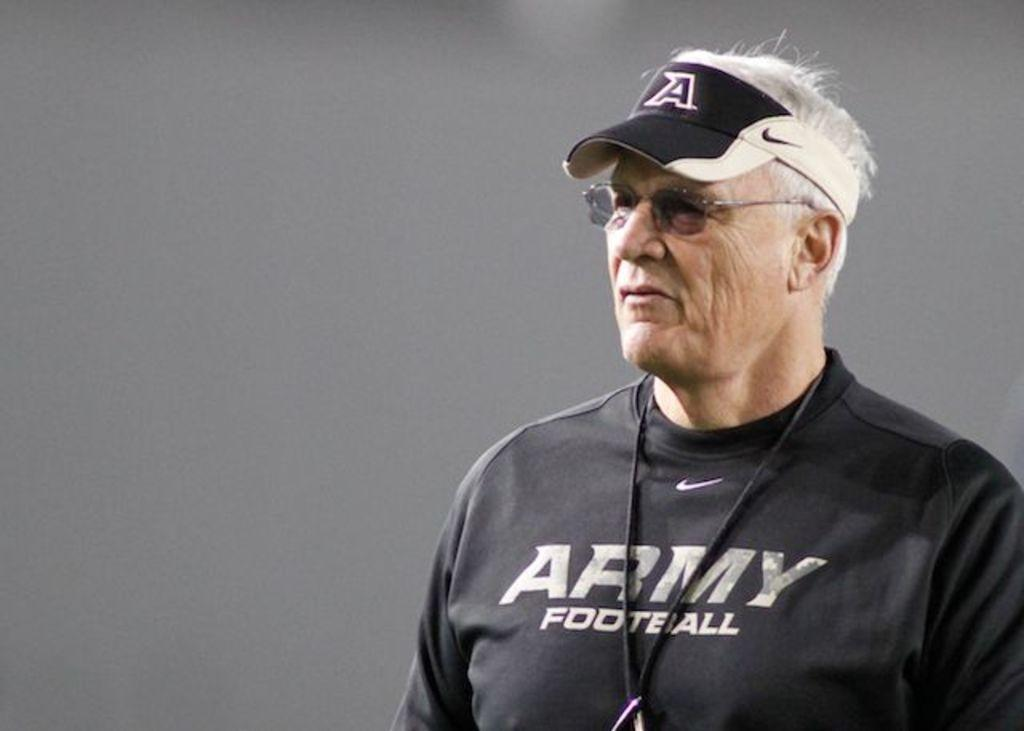<image>
Provide a brief description of the given image. A man in an Army football shirt has a visor and sunglasses on. 